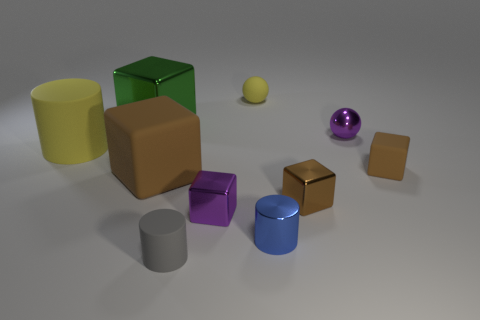What number of balls are blue objects or green things?
Provide a succinct answer. 0. What material is the tiny sphere that is to the left of the small purple ball?
Your answer should be very brief. Rubber. Are there fewer small yellow rubber spheres than tiny cubes?
Your answer should be compact. Yes. There is a brown object that is both behind the brown metallic block and right of the blue metallic thing; what size is it?
Provide a short and direct response. Small. There is a matte cylinder behind the small cube on the right side of the purple metal object that is on the right side of the small yellow matte object; what is its size?
Keep it short and to the point. Large. How many other things are the same color as the small matte sphere?
Provide a succinct answer. 1. Do the rubber block that is on the left side of the tiny gray rubber thing and the small matte block have the same color?
Give a very brief answer. Yes. What number of objects are either big purple matte cubes or small yellow balls?
Make the answer very short. 1. What color is the small cylinder to the right of the yellow rubber ball?
Your response must be concise. Blue. Is the number of tiny balls that are to the left of the brown metal object less than the number of brown rubber objects?
Provide a succinct answer. Yes. 